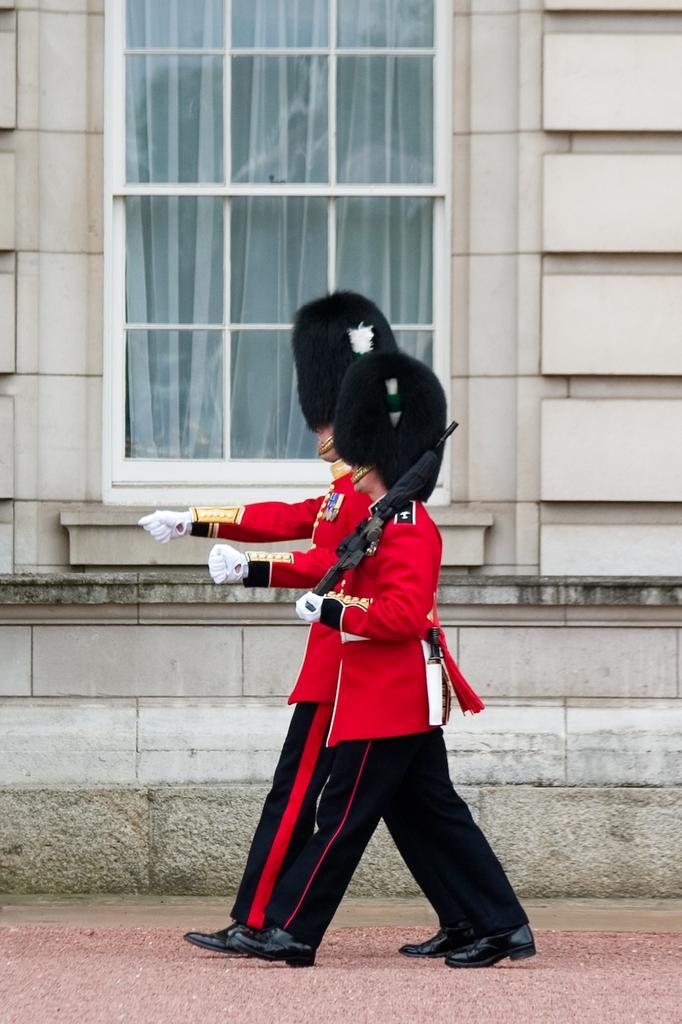Could you give a brief overview of what you see in this image? In this picture I can see couple of them walking and looks like a man holding a gun in his hand and I can see a building in the back and I can see a glass window. 